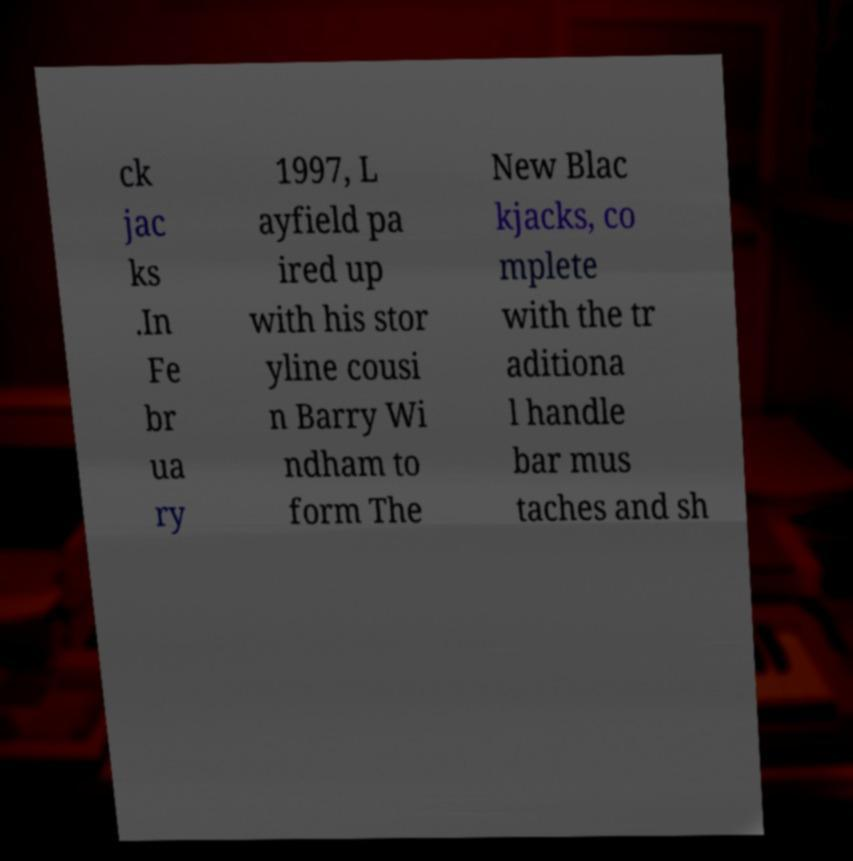What messages or text are displayed in this image? I need them in a readable, typed format. ck jac ks .In Fe br ua ry 1997, L ayfield pa ired up with his stor yline cousi n Barry Wi ndham to form The New Blac kjacks, co mplete with the tr aditiona l handle bar mus taches and sh 